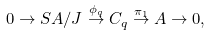Convert formula to latex. <formula><loc_0><loc_0><loc_500><loc_500>0 \to S A / J \stackrel { \phi _ { q } } { \to } C _ { q } \stackrel { \pi _ { 1 } } { \to } A \to 0 ,</formula> 